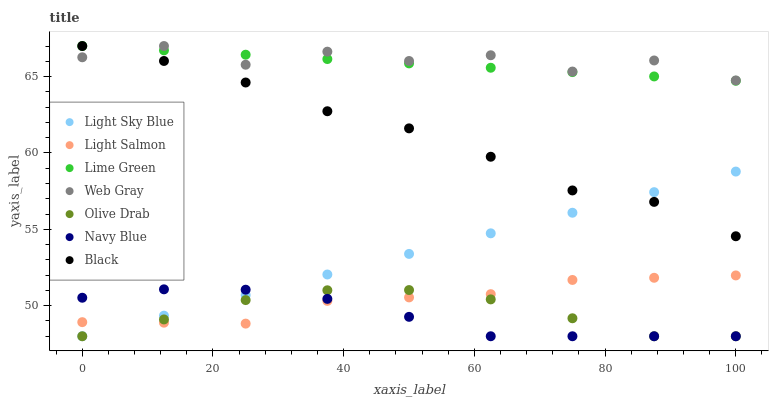Does Navy Blue have the minimum area under the curve?
Answer yes or no. Yes. Does Web Gray have the maximum area under the curve?
Answer yes or no. Yes. Does Web Gray have the minimum area under the curve?
Answer yes or no. No. Does Navy Blue have the maximum area under the curve?
Answer yes or no. No. Is Light Sky Blue the smoothest?
Answer yes or no. Yes. Is Web Gray the roughest?
Answer yes or no. Yes. Is Navy Blue the smoothest?
Answer yes or no. No. Is Navy Blue the roughest?
Answer yes or no. No. Does Navy Blue have the lowest value?
Answer yes or no. Yes. Does Web Gray have the lowest value?
Answer yes or no. No. Does Lime Green have the highest value?
Answer yes or no. Yes. Does Navy Blue have the highest value?
Answer yes or no. No. Is Olive Drab less than Lime Green?
Answer yes or no. Yes. Is Lime Green greater than Navy Blue?
Answer yes or no. Yes. Does Navy Blue intersect Light Sky Blue?
Answer yes or no. Yes. Is Navy Blue less than Light Sky Blue?
Answer yes or no. No. Is Navy Blue greater than Light Sky Blue?
Answer yes or no. No. Does Olive Drab intersect Lime Green?
Answer yes or no. No. 